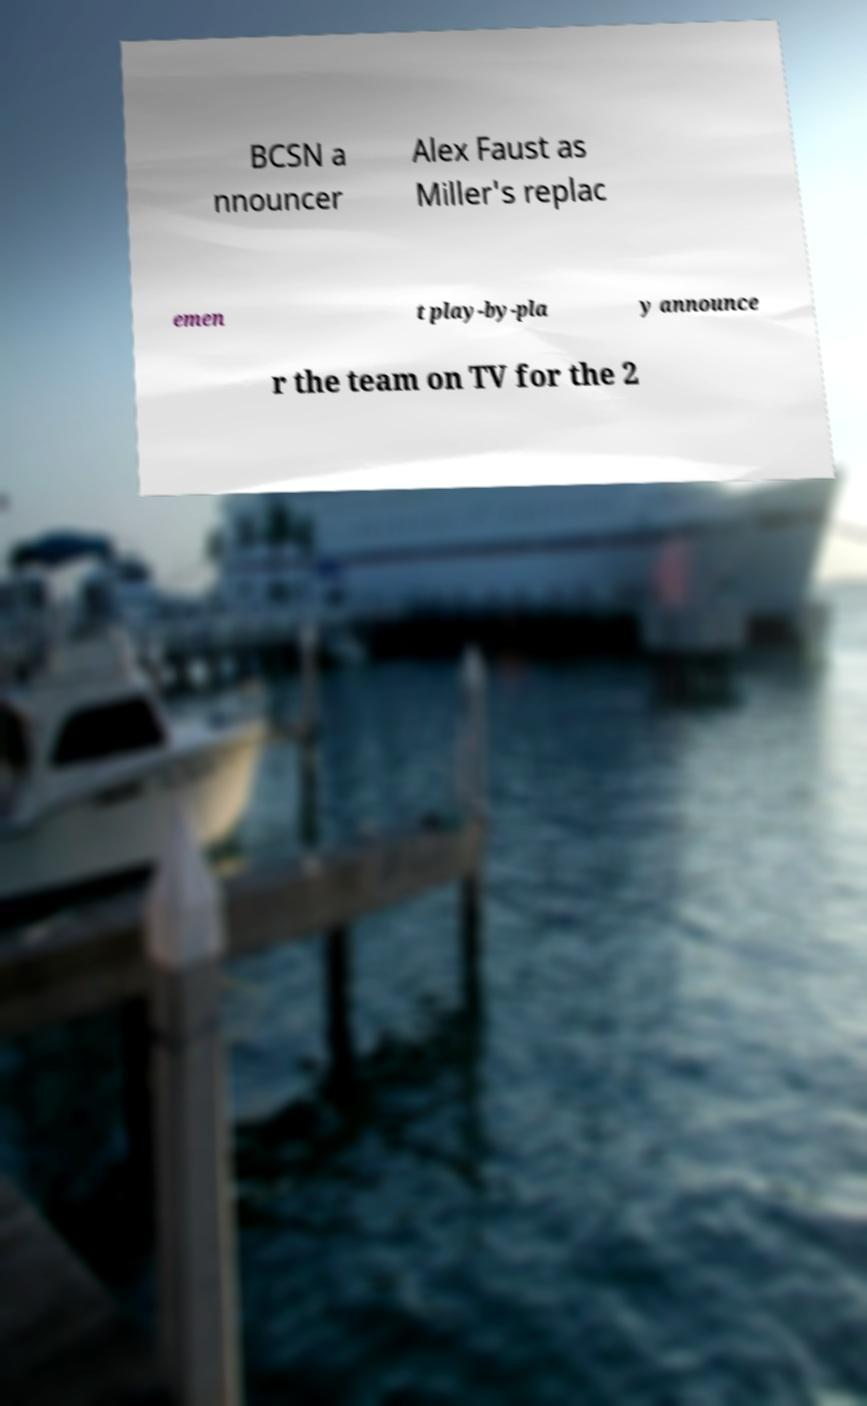Could you assist in decoding the text presented in this image and type it out clearly? BCSN a nnouncer Alex Faust as Miller's replac emen t play-by-pla y announce r the team on TV for the 2 